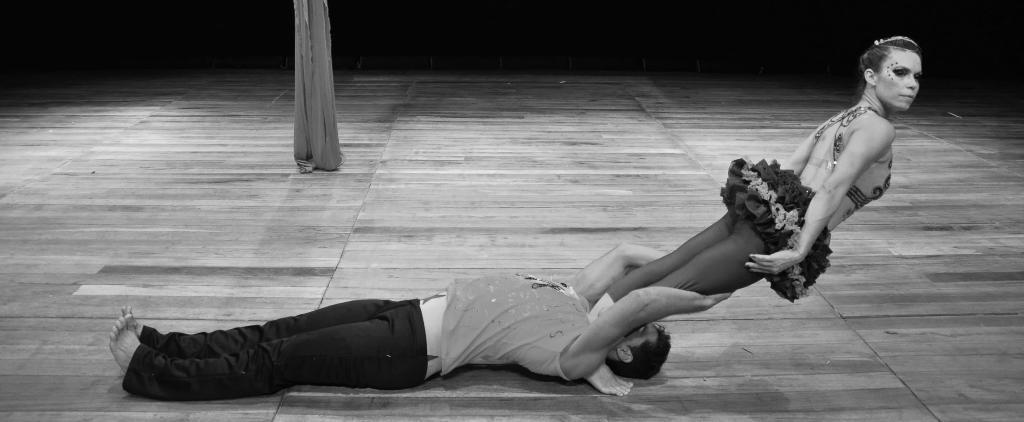Please provide a concise description of this image. In this image we can see a man is lying on the floor, and holding a woman in the hands. 